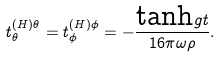<formula> <loc_0><loc_0><loc_500><loc_500>t _ { \theta } ^ { ( H ) \theta } = t _ { \phi } ^ { ( H ) \phi } = - \frac { \text {tanh} g t } { 1 6 \pi \omega \rho } .</formula> 